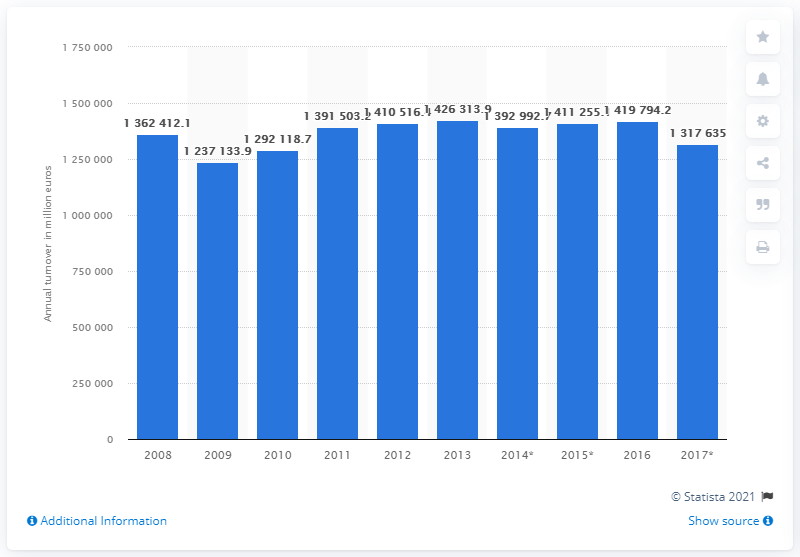Give some essential details in this illustration. In 2015, the turnover of the wholesale and retail trade industry was 141,979,422 dollars. 